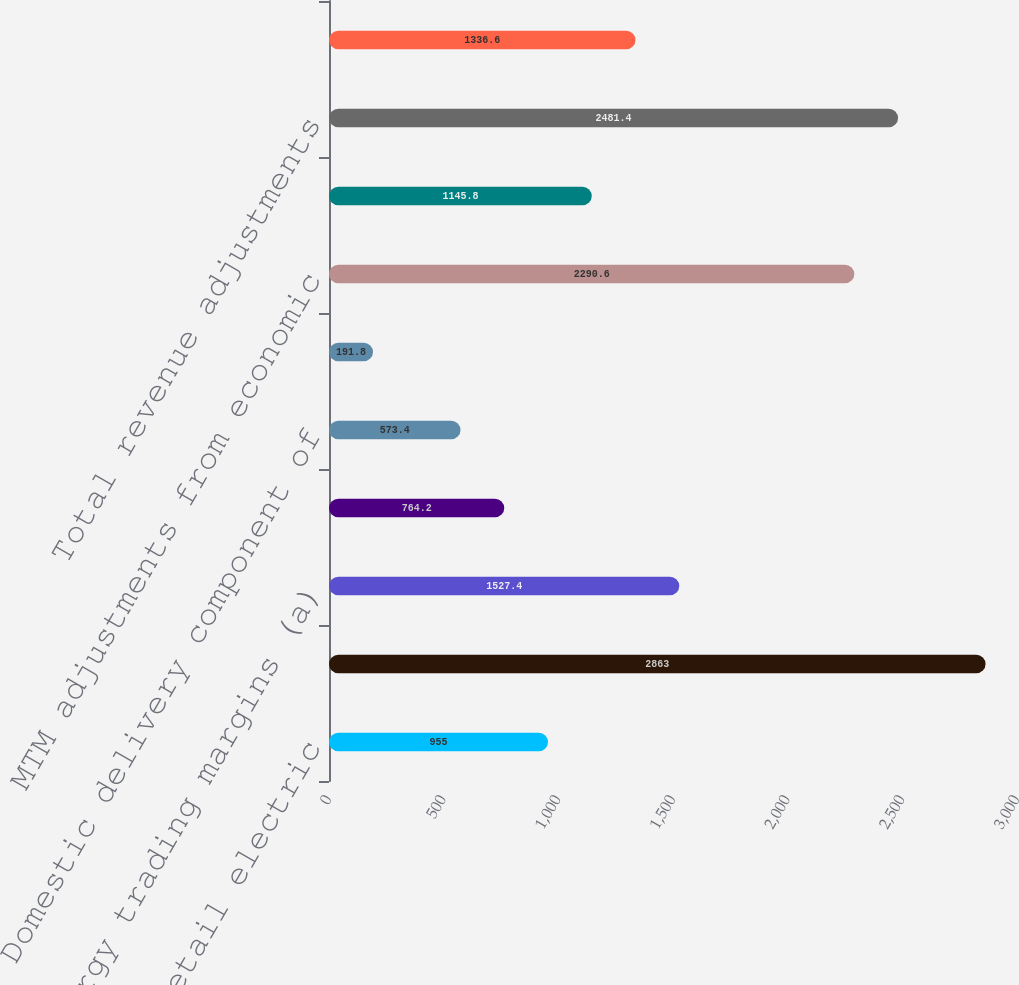Convert chart. <chart><loc_0><loc_0><loc_500><loc_500><bar_chart><fcel>Unregulated retail electric<fcel>Wholesale energy marketing (a)<fcel>Net energy trading margins (a)<fcel>WPD utility revenue<fcel>Domestic delivery component of<fcel>Other utility revenue<fcel>MTM adjustments from economic<fcel>Gains from sale of emission<fcel>Total revenue adjustments<fcel>Fuel (a)<nl><fcel>955<fcel>2863<fcel>1527.4<fcel>764.2<fcel>573.4<fcel>191.8<fcel>2290.6<fcel>1145.8<fcel>2481.4<fcel>1336.6<nl></chart> 